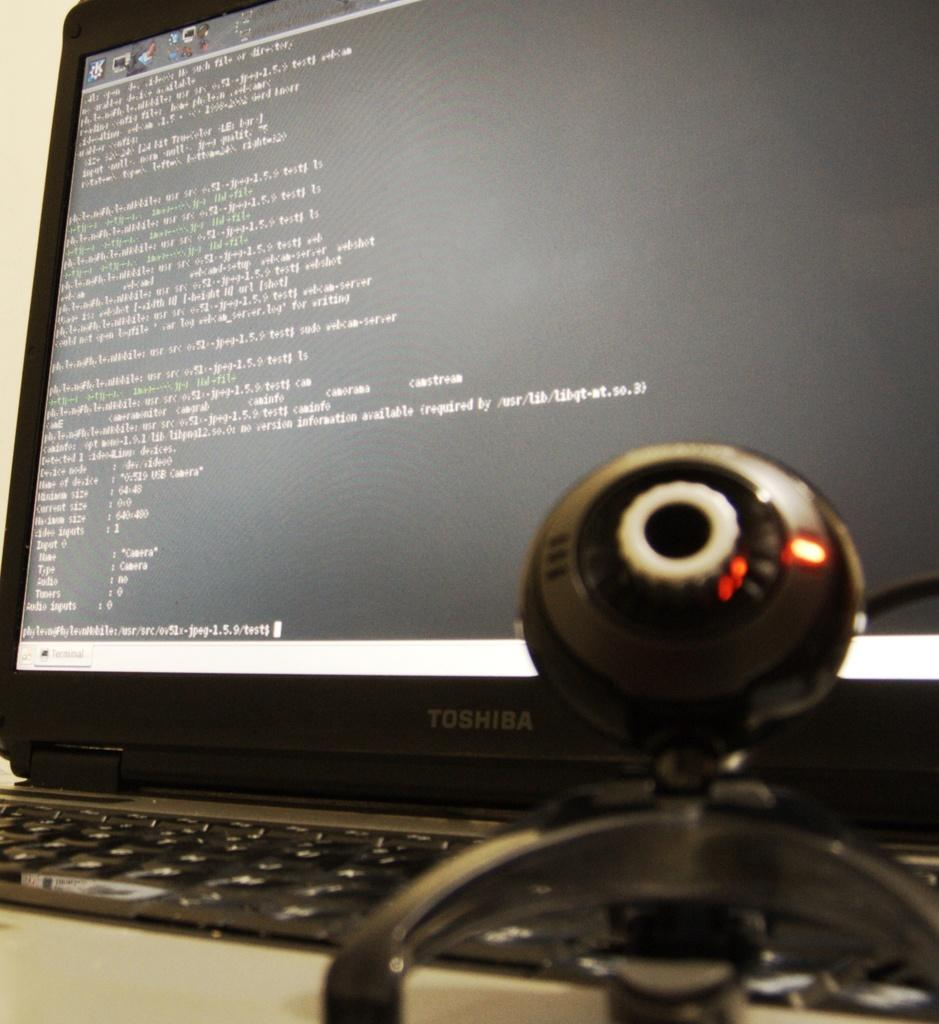<image>
Present a compact description of the photo's key features. A Toshiba laptop running a text based program with an orb shaped webcam. 